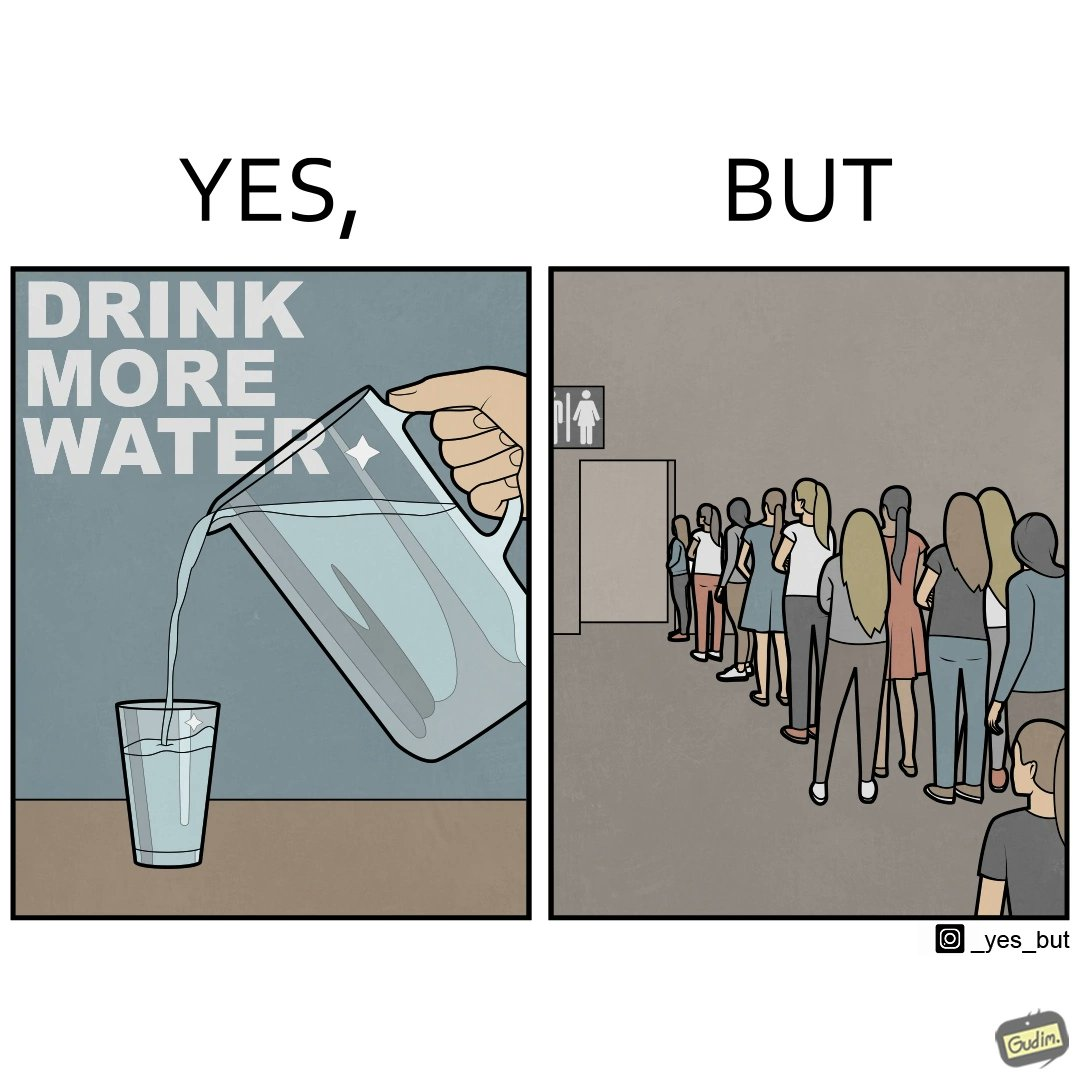What is the satirical meaning behind this image? The image is ironical, as the message "Drink more water" is meant to improve health, but in turn, it would lead to longer queues in front of public toilets, leading to people holding urine for longer periods, in turn leading to deterioration in health. 